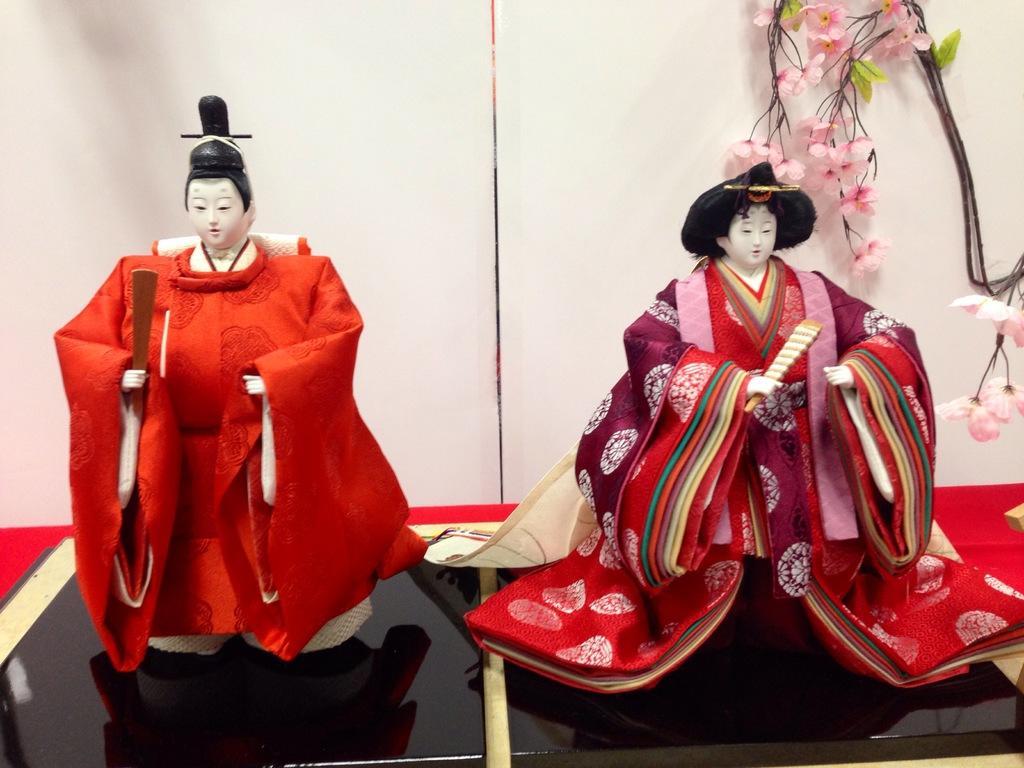Can you describe this image briefly? In the foreground we can see toys on black color tiles. In the background there are flowers, leaves and wall. 